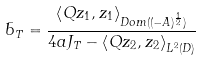<formula> <loc_0><loc_0><loc_500><loc_500>\bar { b } _ { T } = \frac { \left \langle Q z _ { 1 } , z _ { 1 } \right \rangle _ { D o m ( ( - A ) ^ { \frac { 1 } { 2 } } ) } } { 4 a J _ { T } - \left \langle Q z _ { 2 } , z _ { 2 } \right \rangle _ { L ^ { 2 } ( D ) } }</formula> 